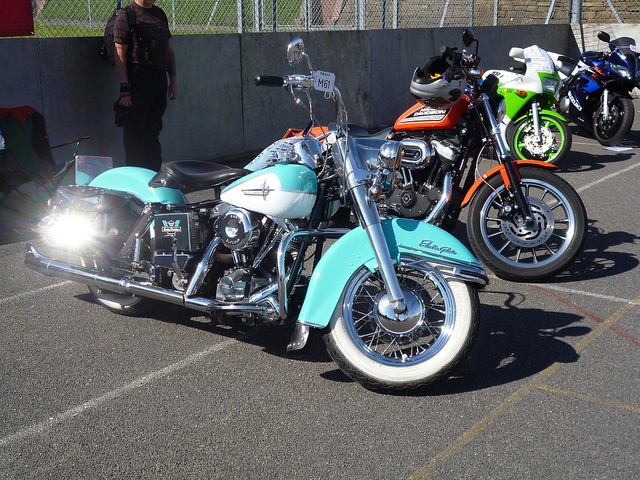Describe the objects in this image and their specific colors. I can see motorcycle in maroon, black, gray, white, and darkgray tones, motorcycle in maroon, black, gray, darkgray, and lightgray tones, people in maroon, black, gray, and brown tones, motorcycle in maroon, black, gray, navy, and white tones, and motorcycle in maroon, white, black, gray, and lime tones in this image. 